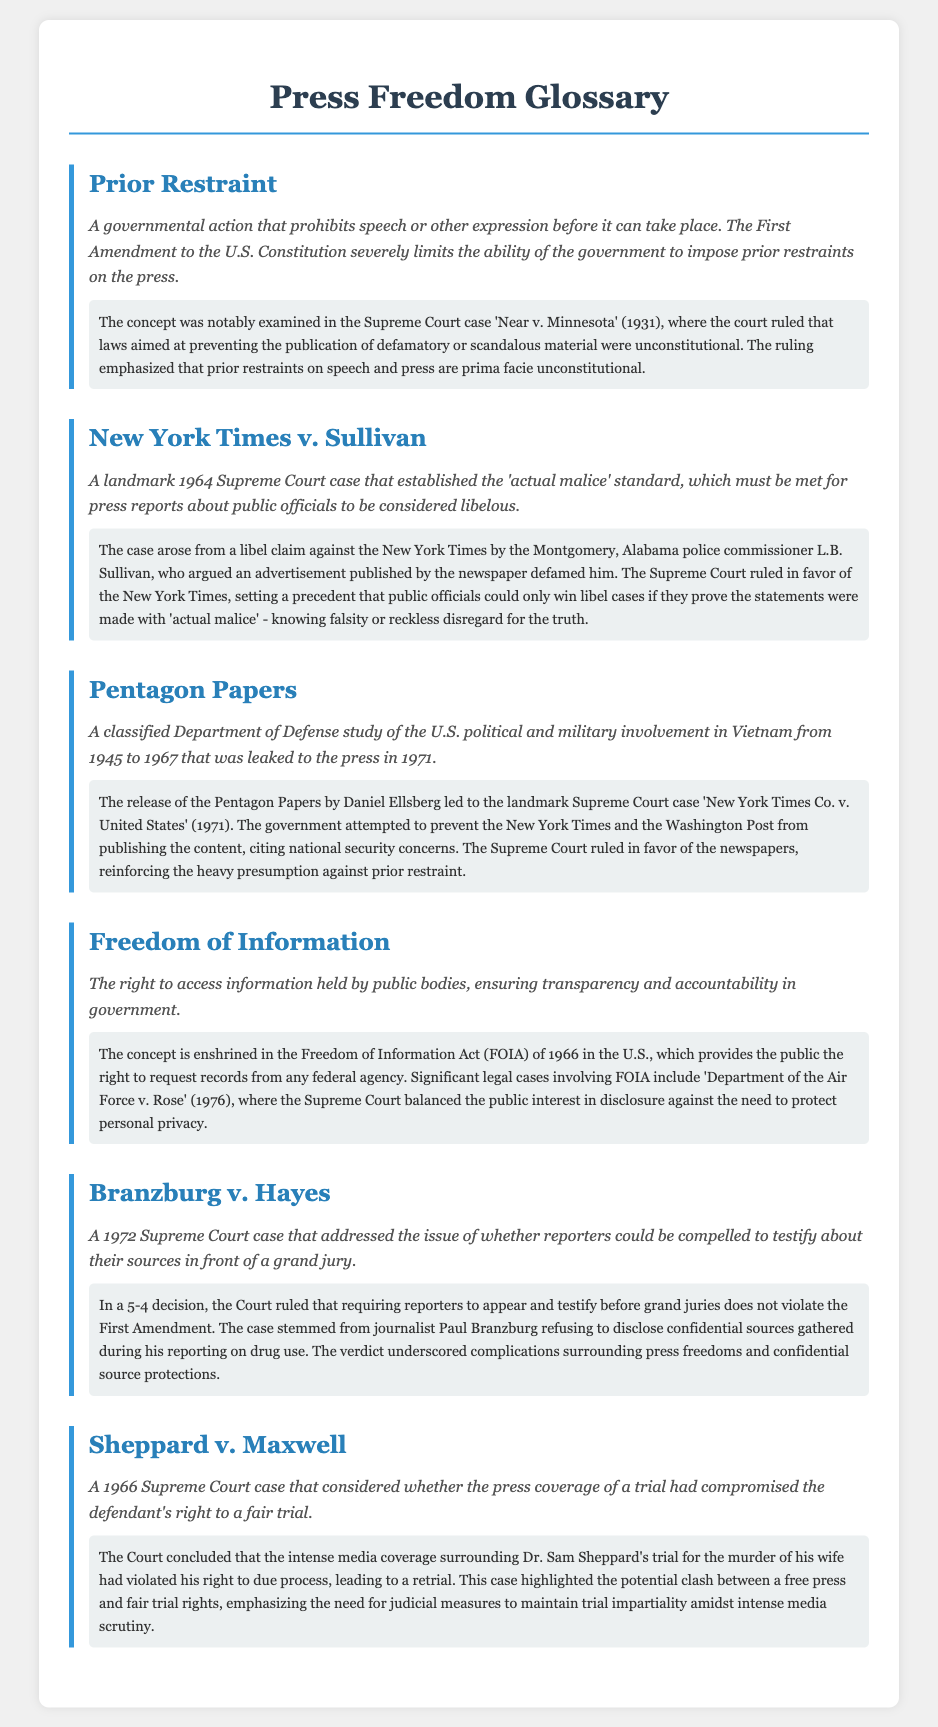What is prior restraint? Prior restraint is defined in the document as a governmental action that prohibits speech or other expression before it can take place.
Answer: A governmental action that prohibits speech or other expression before it can take place Which case established the 'actual malice' standard? The document states that the landmark case establishing the 'actual malice' standard is New York Times v. Sullivan from 1964.
Answer: New York Times v. Sullivan What year did the Pentagon Papers leak occur? The document mentions that the Pentagon Papers were leaked to the press in 1971.
Answer: 1971 What does FOIA stand for? The document indicates that FOIA stands for the Freedom of Information Act.
Answer: Freedom of Information Act What is the main issue in Branzburg v. Hayes? The document describes the main issue as whether reporters could be compelled to testify about their sources in front of a grand jury.
Answer: Whether reporters could be compelled to testify about their sources in front of a grand jury Which case highlighted the clash between a free press and fair trial rights? According to the document, Sheppard v. Maxwell highlighted the clash between a free press and fair trial rights.
Answer: Sheppard v. Maxwell What was the decision of the Supreme Court in Branzburg v. Hayes? The document states that the Supreme Court ruled that requiring reporters to testify before grand juries does not violate the First Amendment.
Answer: Requiring reporters to testify before grand juries does not violate the First Amendment What legal act ensures transparency and accountability in government? The document indicates that the Freedom of Information Act ensures transparency and accountability in government.
Answer: Freedom of Information Act 